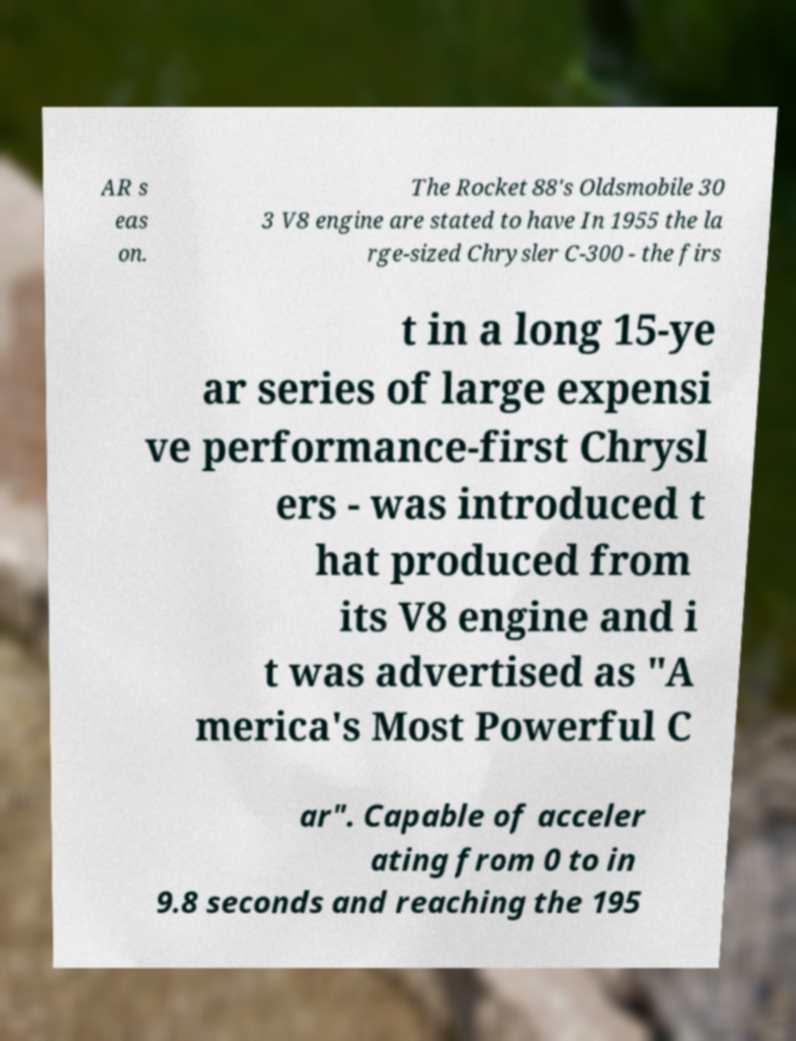Could you extract and type out the text from this image? AR s eas on. The Rocket 88's Oldsmobile 30 3 V8 engine are stated to have In 1955 the la rge-sized Chrysler C-300 - the firs t in a long 15-ye ar series of large expensi ve performance-first Chrysl ers - was introduced t hat produced from its V8 engine and i t was advertised as "A merica's Most Powerful C ar". Capable of acceler ating from 0 to in 9.8 seconds and reaching the 195 